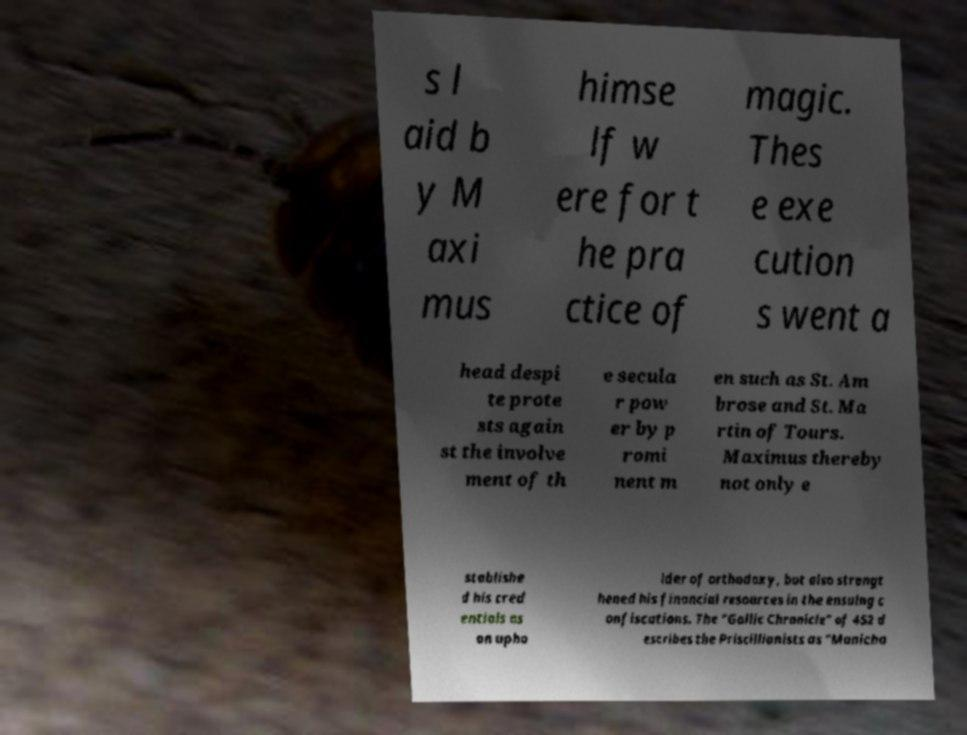Can you accurately transcribe the text from the provided image for me? s l aid b y M axi mus himse lf w ere for t he pra ctice of magic. Thes e exe cution s went a head despi te prote sts again st the involve ment of th e secula r pow er by p romi nent m en such as St. Am brose and St. Ma rtin of Tours. Maximus thereby not only e stablishe d his cred entials as an upho lder of orthodoxy, but also strengt hened his financial resources in the ensuing c onfiscations. The "Gallic Chronicle" of 452 d escribes the Priscillianists as "Manicha 